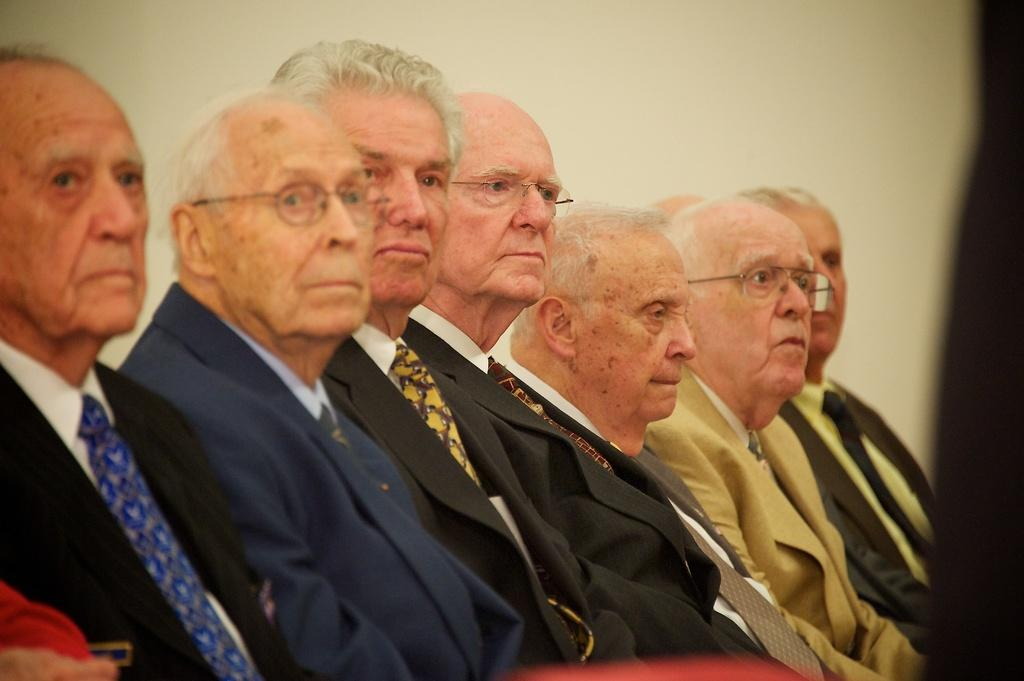How many people are in the image? There are seven men in the image. What are the men doing in the image? The men are sitting. What are the men wearing in the image? The men are wearing suits. How many of the men are wearing spectacles? Three of the men are wearing spectacles. What can be seen in the background of the image? There is a wall in the background of the image. What is the texture of the dress worn by the man in the image? There are no men wearing dresses in the image; they are all wearing suits. 